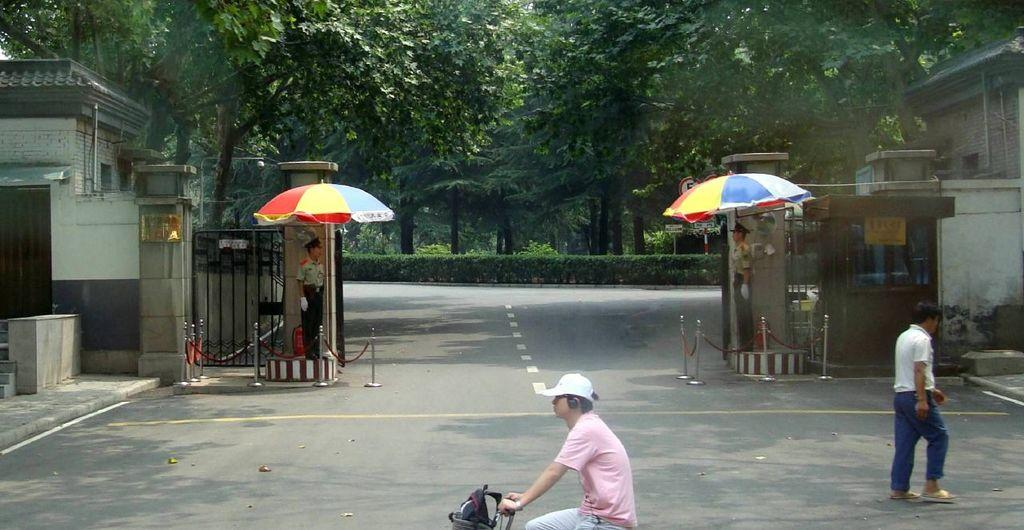What type of structures can be seen in the image? There are buildings in the image. What safety feature is present in the image? Barrier poles are present in the image. What are the persons standing under in the image? The persons are standing under parasols in the image. Can you describe the person's position in the image? A person is standing on the road in the image. What mode of transportation is being used by a person in the image? A person is riding a bicycle in the image. What type of vegetation is visible in the image? Bushes, plants, and trees are visible in the image. What type of desk can be seen in the image? There is no desk present in the image. 